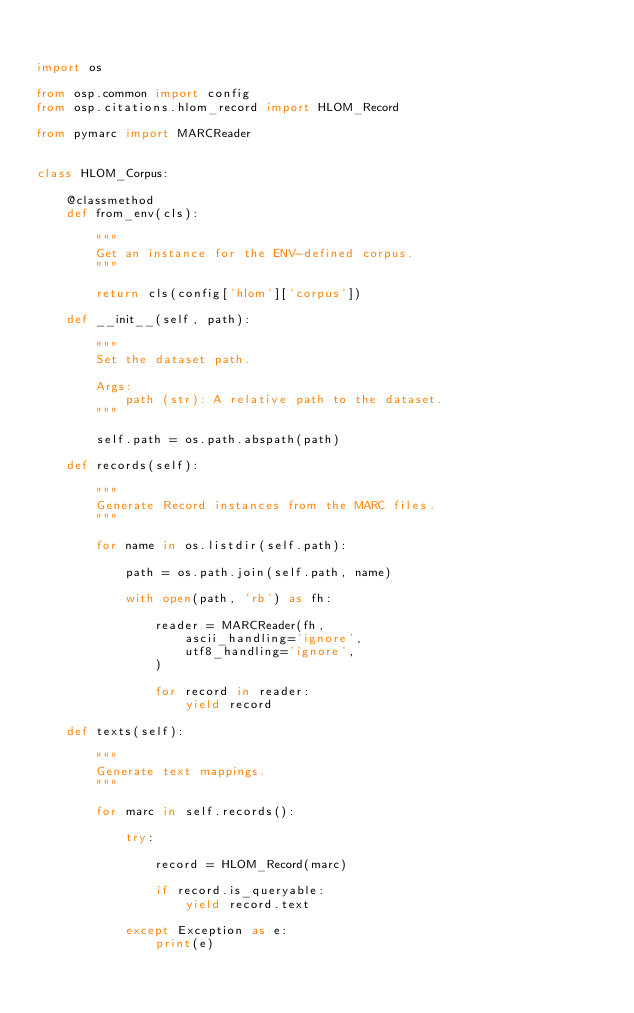<code> <loc_0><loc_0><loc_500><loc_500><_Python_>

import os

from osp.common import config
from osp.citations.hlom_record import HLOM_Record

from pymarc import MARCReader


class HLOM_Corpus:

    @classmethod
    def from_env(cls):

        """
        Get an instance for the ENV-defined corpus.
        """

        return cls(config['hlom']['corpus'])

    def __init__(self, path):

        """
        Set the dataset path.

        Args:
            path (str): A relative path to the dataset.
        """

        self.path = os.path.abspath(path)

    def records(self):

        """
        Generate Record instances from the MARC files.
        """

        for name in os.listdir(self.path):

            path = os.path.join(self.path, name)

            with open(path, 'rb') as fh:

                reader = MARCReader(fh,
                    ascii_handling='ignore',
                    utf8_handling='ignore',
                )

                for record in reader:
                    yield record

    def texts(self):

        """
        Generate text mappings.
        """

        for marc in self.records():

            try:

                record = HLOM_Record(marc)

                if record.is_queryable:
                    yield record.text

            except Exception as e:
                print(e)
</code> 